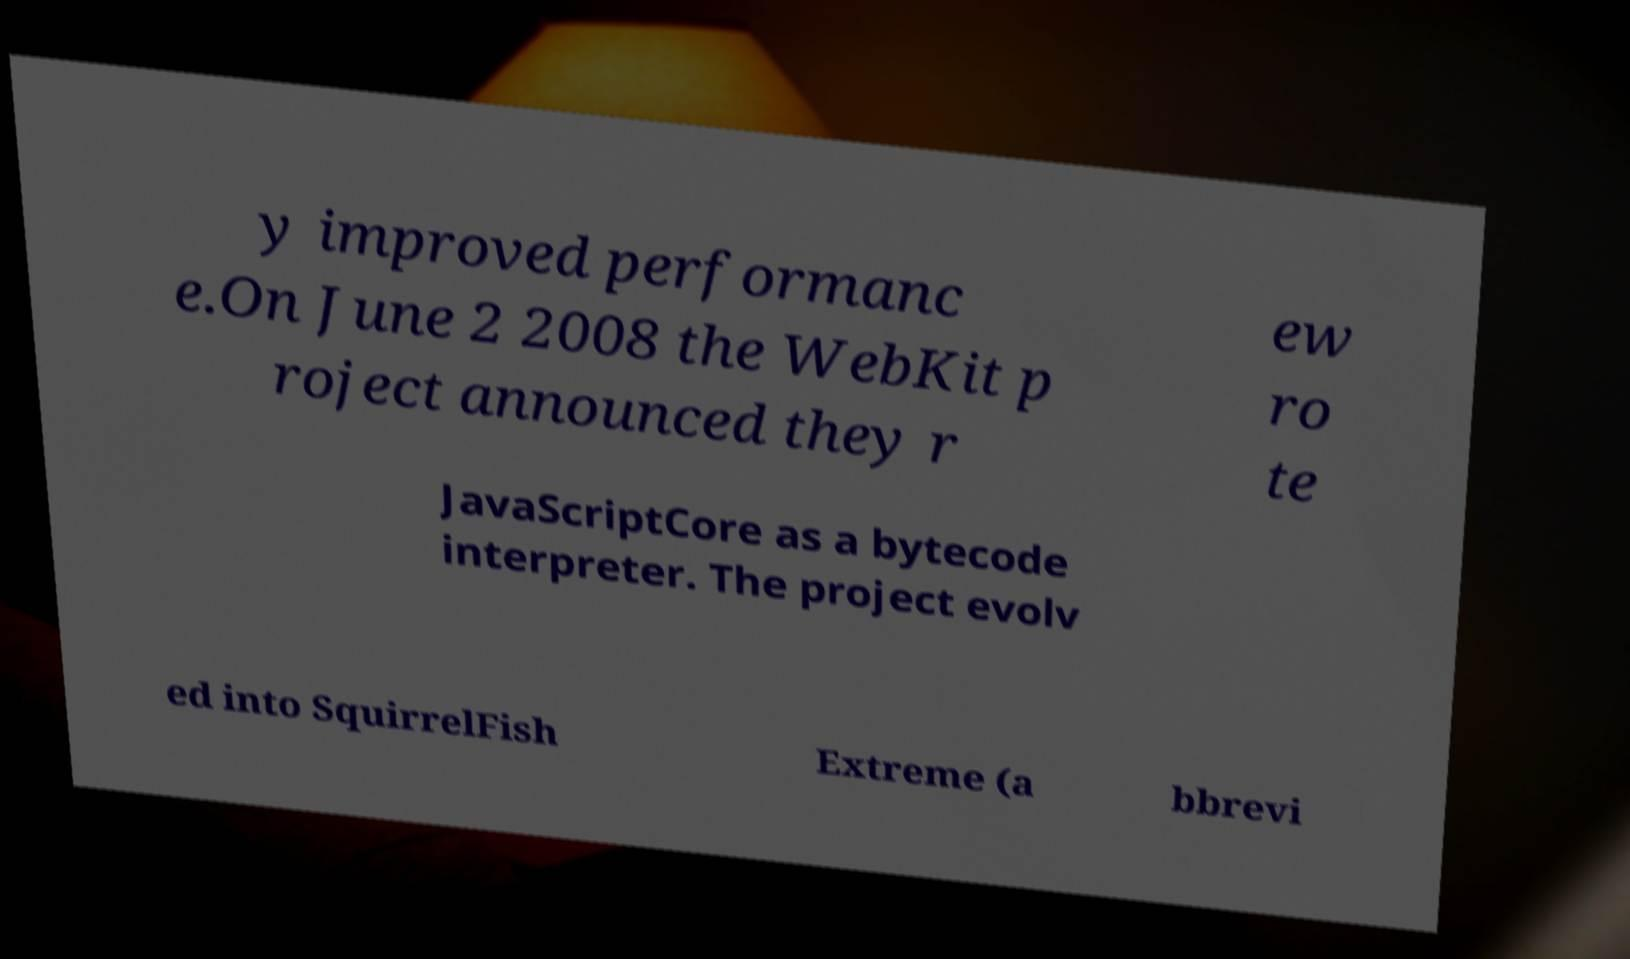Can you read and provide the text displayed in the image?This photo seems to have some interesting text. Can you extract and type it out for me? y improved performanc e.On June 2 2008 the WebKit p roject announced they r ew ro te JavaScriptCore as a bytecode interpreter. The project evolv ed into SquirrelFish Extreme (a bbrevi 